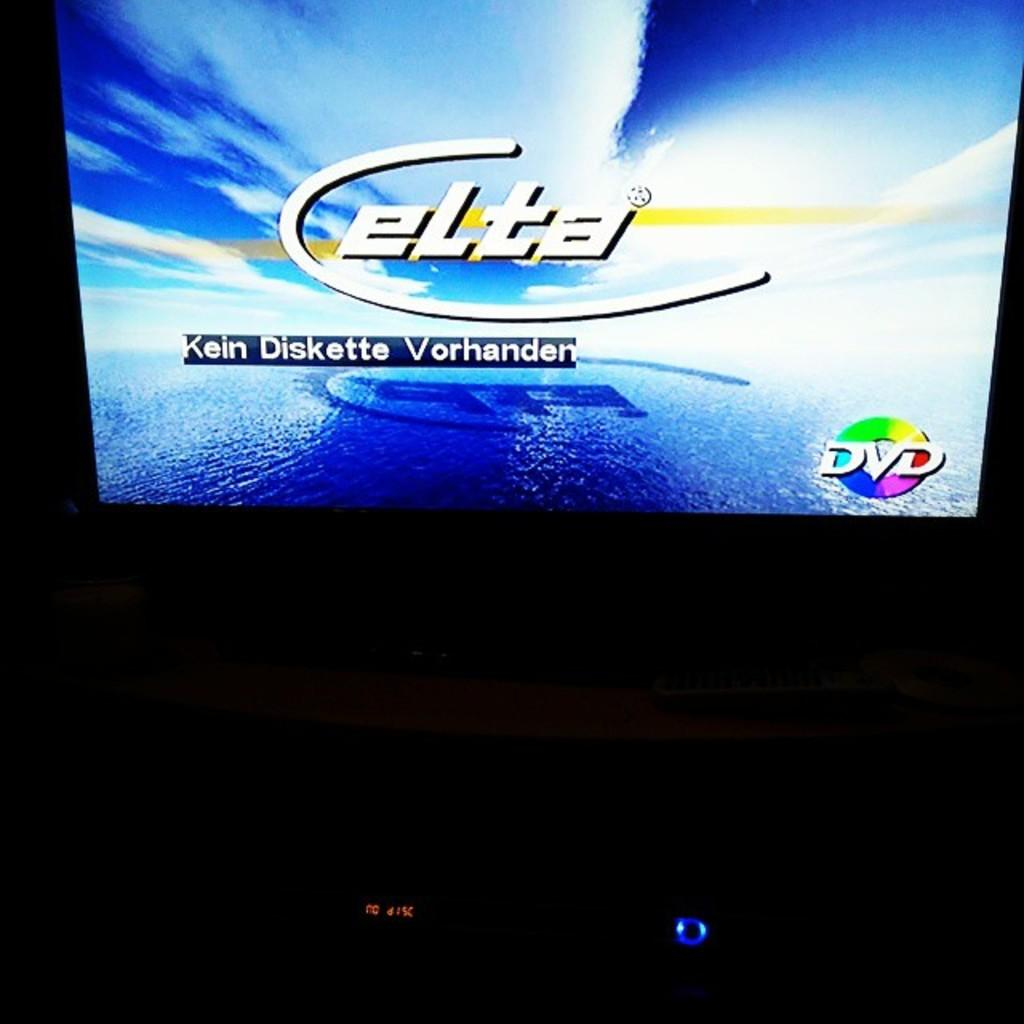<image>
Provide a brief description of the given image. Elta Kein Diskette Vorhanded wrote on a television that playing a dvd 